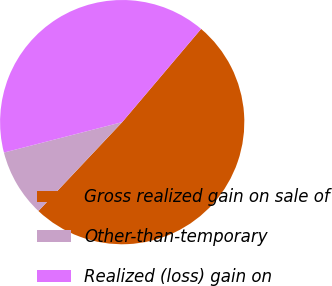Convert chart to OTSL. <chart><loc_0><loc_0><loc_500><loc_500><pie_chart><fcel>Gross realized gain on sale of<fcel>Other-than-temporary<fcel>Realized (loss) gain on<nl><fcel>50.85%<fcel>8.96%<fcel>40.19%<nl></chart> 